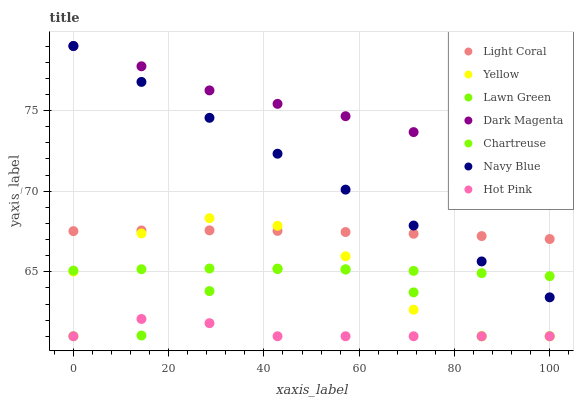Does Hot Pink have the minimum area under the curve?
Answer yes or no. Yes. Does Dark Magenta have the maximum area under the curve?
Answer yes or no. Yes. Does Navy Blue have the minimum area under the curve?
Answer yes or no. No. Does Navy Blue have the maximum area under the curve?
Answer yes or no. No. Is Navy Blue the smoothest?
Answer yes or no. Yes. Is Lawn Green the roughest?
Answer yes or no. Yes. Is Dark Magenta the smoothest?
Answer yes or no. No. Is Dark Magenta the roughest?
Answer yes or no. No. Does Lawn Green have the lowest value?
Answer yes or no. Yes. Does Navy Blue have the lowest value?
Answer yes or no. No. Does Navy Blue have the highest value?
Answer yes or no. Yes. Does Hot Pink have the highest value?
Answer yes or no. No. Is Lawn Green less than Light Coral?
Answer yes or no. Yes. Is Light Coral greater than Hot Pink?
Answer yes or no. Yes. Does Yellow intersect Light Coral?
Answer yes or no. Yes. Is Yellow less than Light Coral?
Answer yes or no. No. Is Yellow greater than Light Coral?
Answer yes or no. No. Does Lawn Green intersect Light Coral?
Answer yes or no. No. 